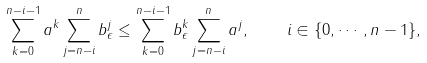Convert formula to latex. <formula><loc_0><loc_0><loc_500><loc_500>\sum _ { k = 0 } ^ { n - i - 1 } a ^ { k } \sum _ { j = n - i } ^ { n } b _ { \epsilon } ^ { j } \leq \sum _ { k = 0 } ^ { n - i - 1 } b _ { \epsilon } ^ { k } \sum _ { j = n - i } ^ { n } a ^ { j } , \quad i \in \{ 0 , \cdots , n - 1 \} ,</formula> 